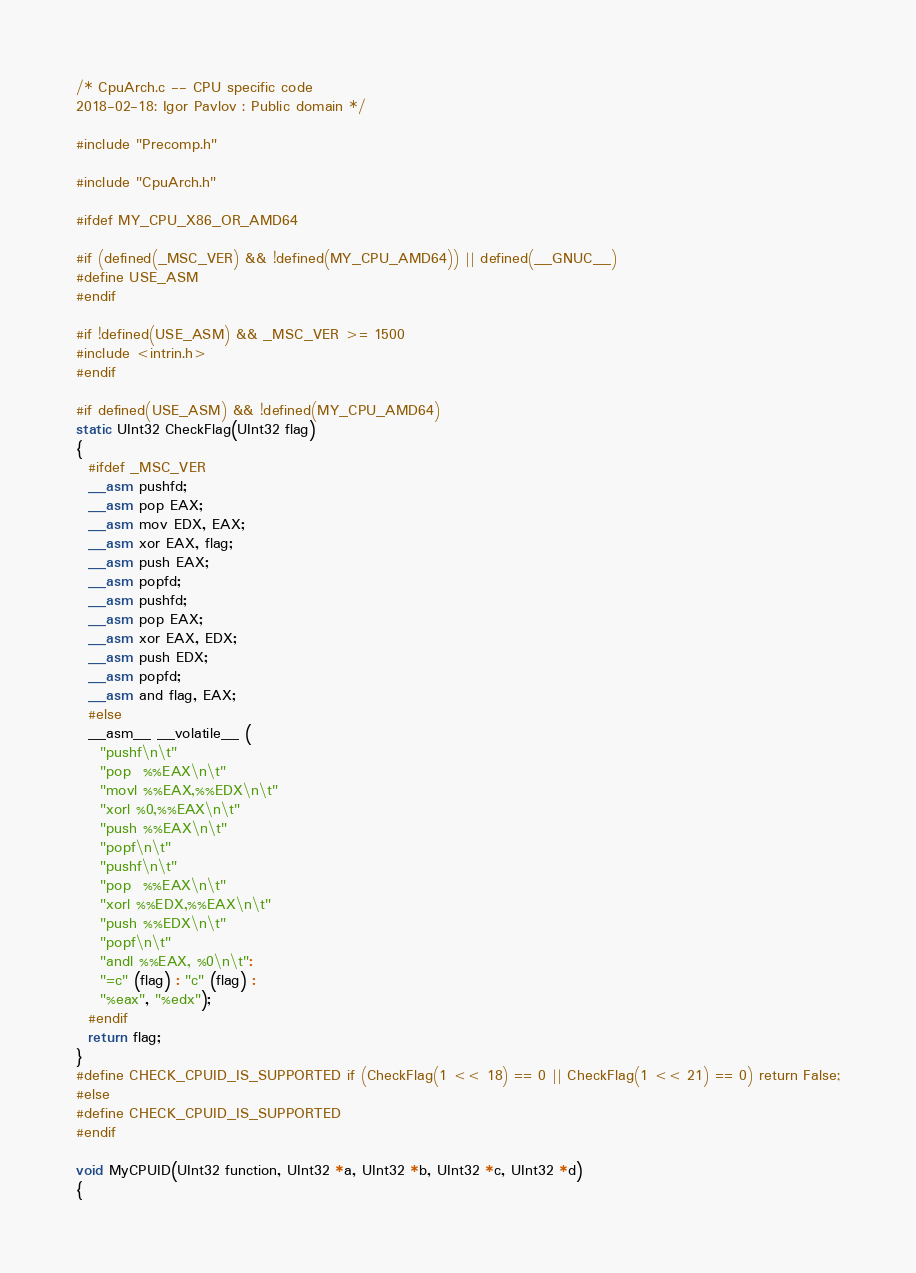<code> <loc_0><loc_0><loc_500><loc_500><_C_>/* CpuArch.c -- CPU specific code
2018-02-18: Igor Pavlov : Public domain */

#include "Precomp.h"

#include "CpuArch.h"

#ifdef MY_CPU_X86_OR_AMD64

#if (defined(_MSC_VER) && !defined(MY_CPU_AMD64)) || defined(__GNUC__)
#define USE_ASM
#endif

#if !defined(USE_ASM) && _MSC_VER >= 1500
#include <intrin.h>
#endif

#if defined(USE_ASM) && !defined(MY_CPU_AMD64)
static UInt32 CheckFlag(UInt32 flag)
{
  #ifdef _MSC_VER
  __asm pushfd;
  __asm pop EAX;
  __asm mov EDX, EAX;
  __asm xor EAX, flag;
  __asm push EAX;
  __asm popfd;
  __asm pushfd;
  __asm pop EAX;
  __asm xor EAX, EDX;
  __asm push EDX;
  __asm popfd;
  __asm and flag, EAX;
  #else
  __asm__ __volatile__ (
    "pushf\n\t"
    "pop  %%EAX\n\t"
    "movl %%EAX,%%EDX\n\t"
    "xorl %0,%%EAX\n\t"
    "push %%EAX\n\t"
    "popf\n\t"
    "pushf\n\t"
    "pop  %%EAX\n\t"
    "xorl %%EDX,%%EAX\n\t"
    "push %%EDX\n\t"
    "popf\n\t"
    "andl %%EAX, %0\n\t":
    "=c" (flag) : "c" (flag) :
    "%eax", "%edx");
  #endif
  return flag;
}
#define CHECK_CPUID_IS_SUPPORTED if (CheckFlag(1 << 18) == 0 || CheckFlag(1 << 21) == 0) return False;
#else
#define CHECK_CPUID_IS_SUPPORTED
#endif

void MyCPUID(UInt32 function, UInt32 *a, UInt32 *b, UInt32 *c, UInt32 *d)
{</code> 